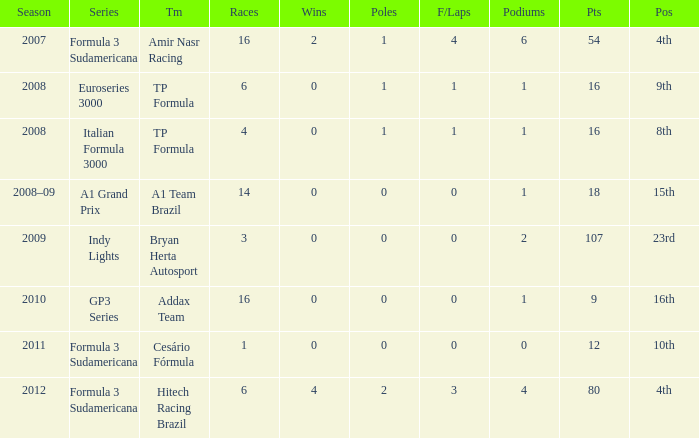What team did he compete for in the GP3 series? Addax Team. 